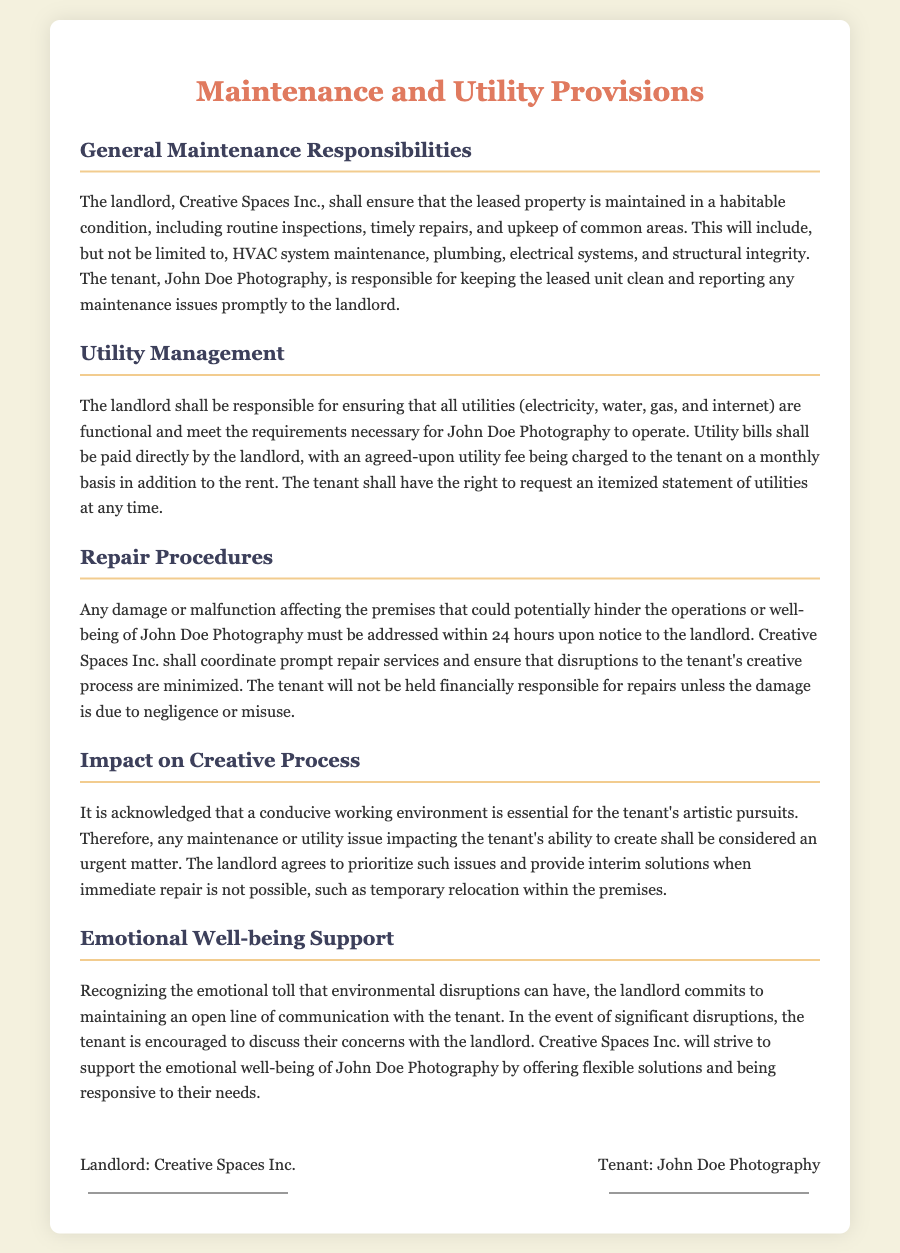What is the name of the landlord? The name of the landlord is stated in the document as Creative Spaces Inc.
Answer: Creative Spaces Inc Who is responsible for keeping the leased unit clean? The document states that the tenant, John Doe Photography, is responsible for keeping the leased unit clean.
Answer: John Doe Photography What must be addressed within 24 hours? According to the document, any damage or malfunction affecting the premises must be addressed within 24 hours.
Answer: Any damage or malfunction What is included in the utility management responsibility? The landlord is responsible for ensuring that all utilities (electricity, water, gas, and internet) are functional.
Answer: All utilities What should the tenant do if there are significant disruptions? The tenant is encouraged to discuss their concerns with the landlord during significant disruptions.
Answer: Discuss their concerns What kind of fees will the tenant be charged for utilities? An agreed-upon utility fee will be charged to the tenant on a monthly basis in addition to the rent.
Answer: Utility fee Who will coordinate prompt repair services? The document states that Creative Spaces Inc. shall coordinate prompt repair services.
Answer: Creative Spaces Inc How will the landlord support emotional well-being? The landlord commits to maintaining an open line of communication with the tenant.
Answer: Open line of communication 